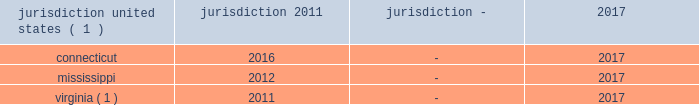And penalties , resulting in a liability of $ 1 million for interest and penalties as of december 31 , 2018 .
In 2017 , there was a net decrease in income tax expense of $ 1 million for interest and penalties , resulting in no material liability for interest and penalties as of december 31 , 2017 .
The 2017 changes in interest and penalties related to statute of limitation expirations .
In 2016 , there was a net decrease in income tax expense of $ 2 million for interest and penalties , resulting in a total liability of $ 1 million for interest and penalties as of december 31 , 2016 .
The 2016 changes in interest and penalties related to reductions in prior year tax positions and settlement with a taxing authority .
The table summarizes the tax years that are either currently under examination or remain open under the applicable statute of limitations and subject to examination by the major tax jurisdictions in which the company operates: .
Virginia ( 1 ) 2011 - 2017 ( 1 ) the 2014 tax year has been closed in these jurisdictions .
Although the company believes it has adequately provided for all uncertain tax positions , amounts asserted by taxing authorities could be greater than the company's accrued position .
Accordingly , additional provisions for federal and state income tax related matters could be recorded in the future as revised estimates are made or the underlying matters are effectively settled or otherwise resolved .
Conversely , the company could settle positions with the tax authorities for amounts lower than have been accrued .
The company believes that it is reasonably possible that during the next 12 months the company's liability for uncertain tax positions may decrease by $ 14 million due to resolution of a federal uncertain tax position .
During 2013 the company entered into the pre-compliance assurance process with the irs for years 2011 and 2012 .
The company is part of the irs compliance assurance process program for the 2014 through 2018 tax years .
Open tax years related to state jurisdictions remain subject to examination .
Deferred income taxes - deferred income taxes reflect the net tax effects of temporary differences between the carrying amounts of assets and liabilities for financial reporting purposes and for income tax purposes .
As described above , deferred tax assets and liabilities are calculated as of the balance sheet date using current tax laws and rates expected to be in effect when the deferred tax items reverse in future periods .
As a result of the reduction in the corporate income tax rate from 35% ( 35 % ) to 21% ( 21 % ) under the tax act , the company revalued its net deferred tax assets as of december 31 , 2017 .
Net deferred tax assets are classified as long-term deferred tax assets in the consolidated statements of financial position. .
What is the liability for interest and penalties as of december 31 , 2016? 
Computations: ((1 + 2) - 2)
Answer: 1.0. 